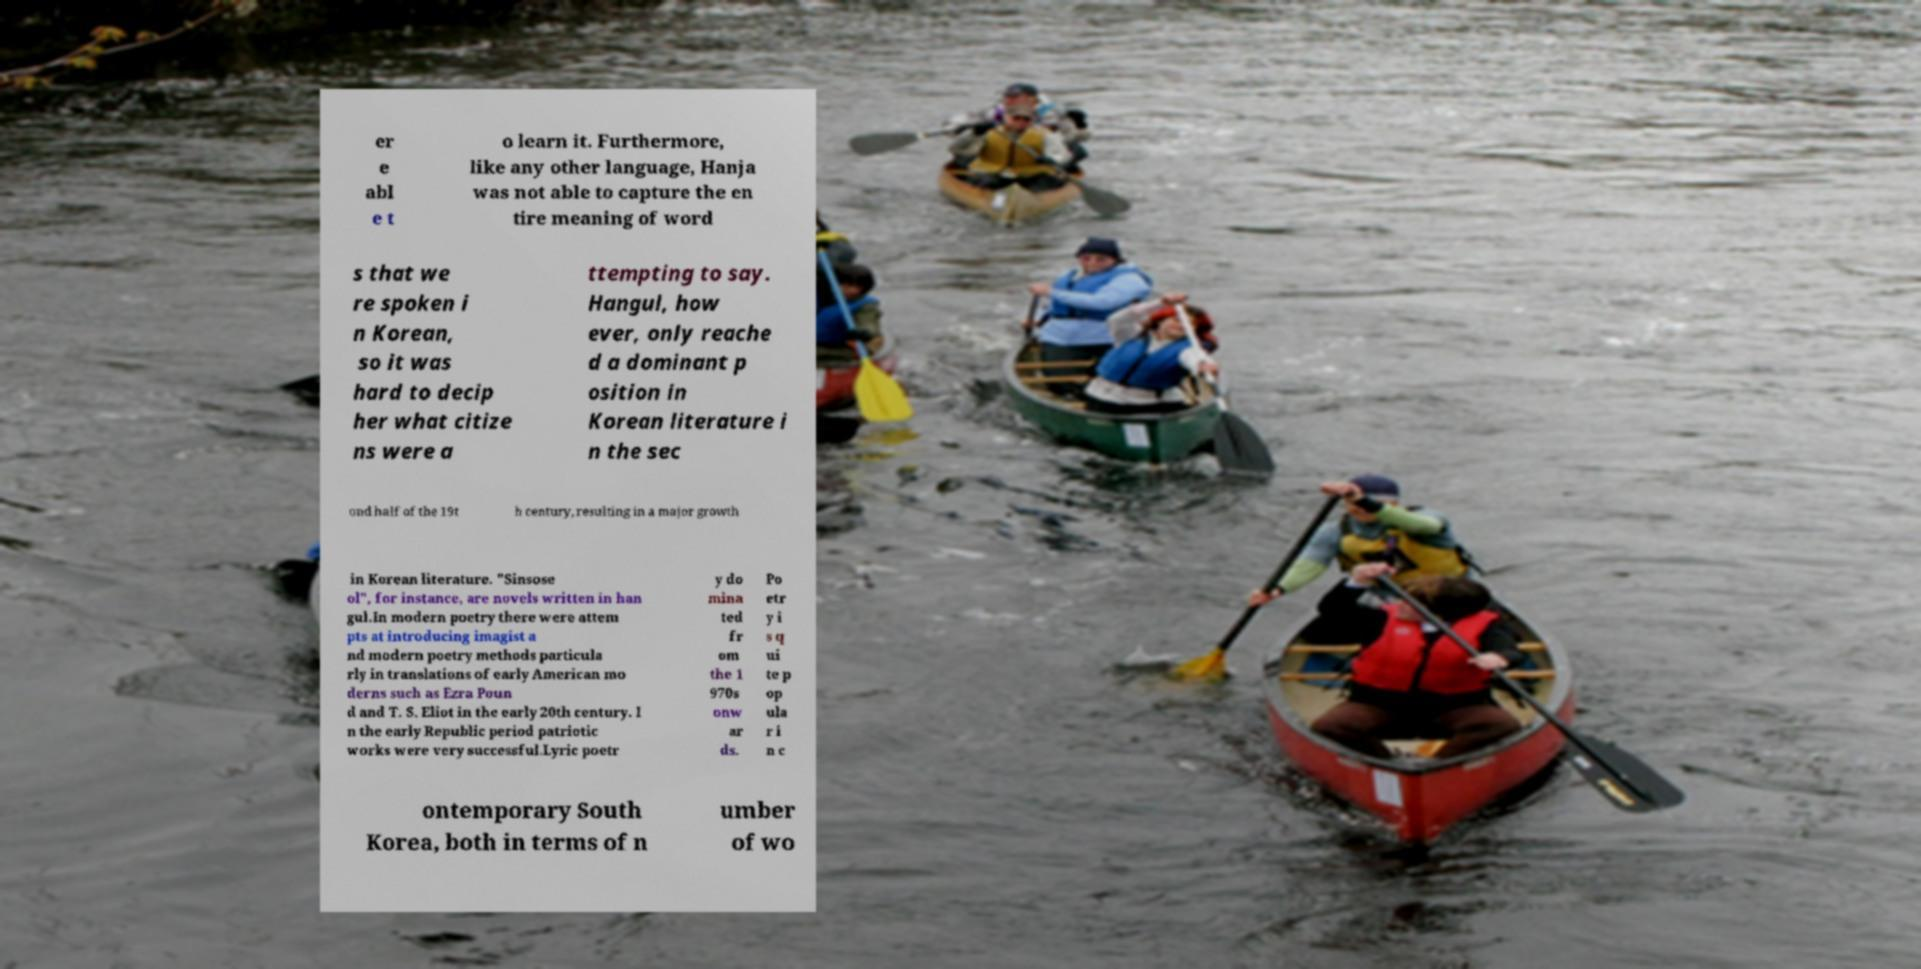Could you assist in decoding the text presented in this image and type it out clearly? er e abl e t o learn it. Furthermore, like any other language, Hanja was not able to capture the en tire meaning of word s that we re spoken i n Korean, so it was hard to decip her what citize ns were a ttempting to say. Hangul, how ever, only reache d a dominant p osition in Korean literature i n the sec ond half of the 19t h century, resulting in a major growth in Korean literature. "Sinsose ol", for instance, are novels written in han gul.In modern poetry there were attem pts at introducing imagist a nd modern poetry methods particula rly in translations of early American mo derns such as Ezra Poun d and T. S. Eliot in the early 20th century. I n the early Republic period patriotic works were very successful.Lyric poetr y do mina ted fr om the 1 970s onw ar ds. Po etr y i s q ui te p op ula r i n c ontemporary South Korea, both in terms of n umber of wo 